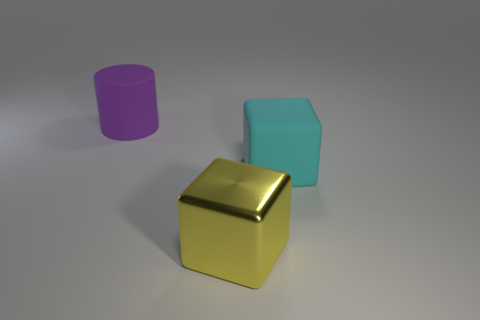How many other things are there of the same material as the purple cylinder? After examining the image, it appears that the gold cube shares the same smooth, shiny material attribute as the purple cylinder, making it one other object of the same material. 